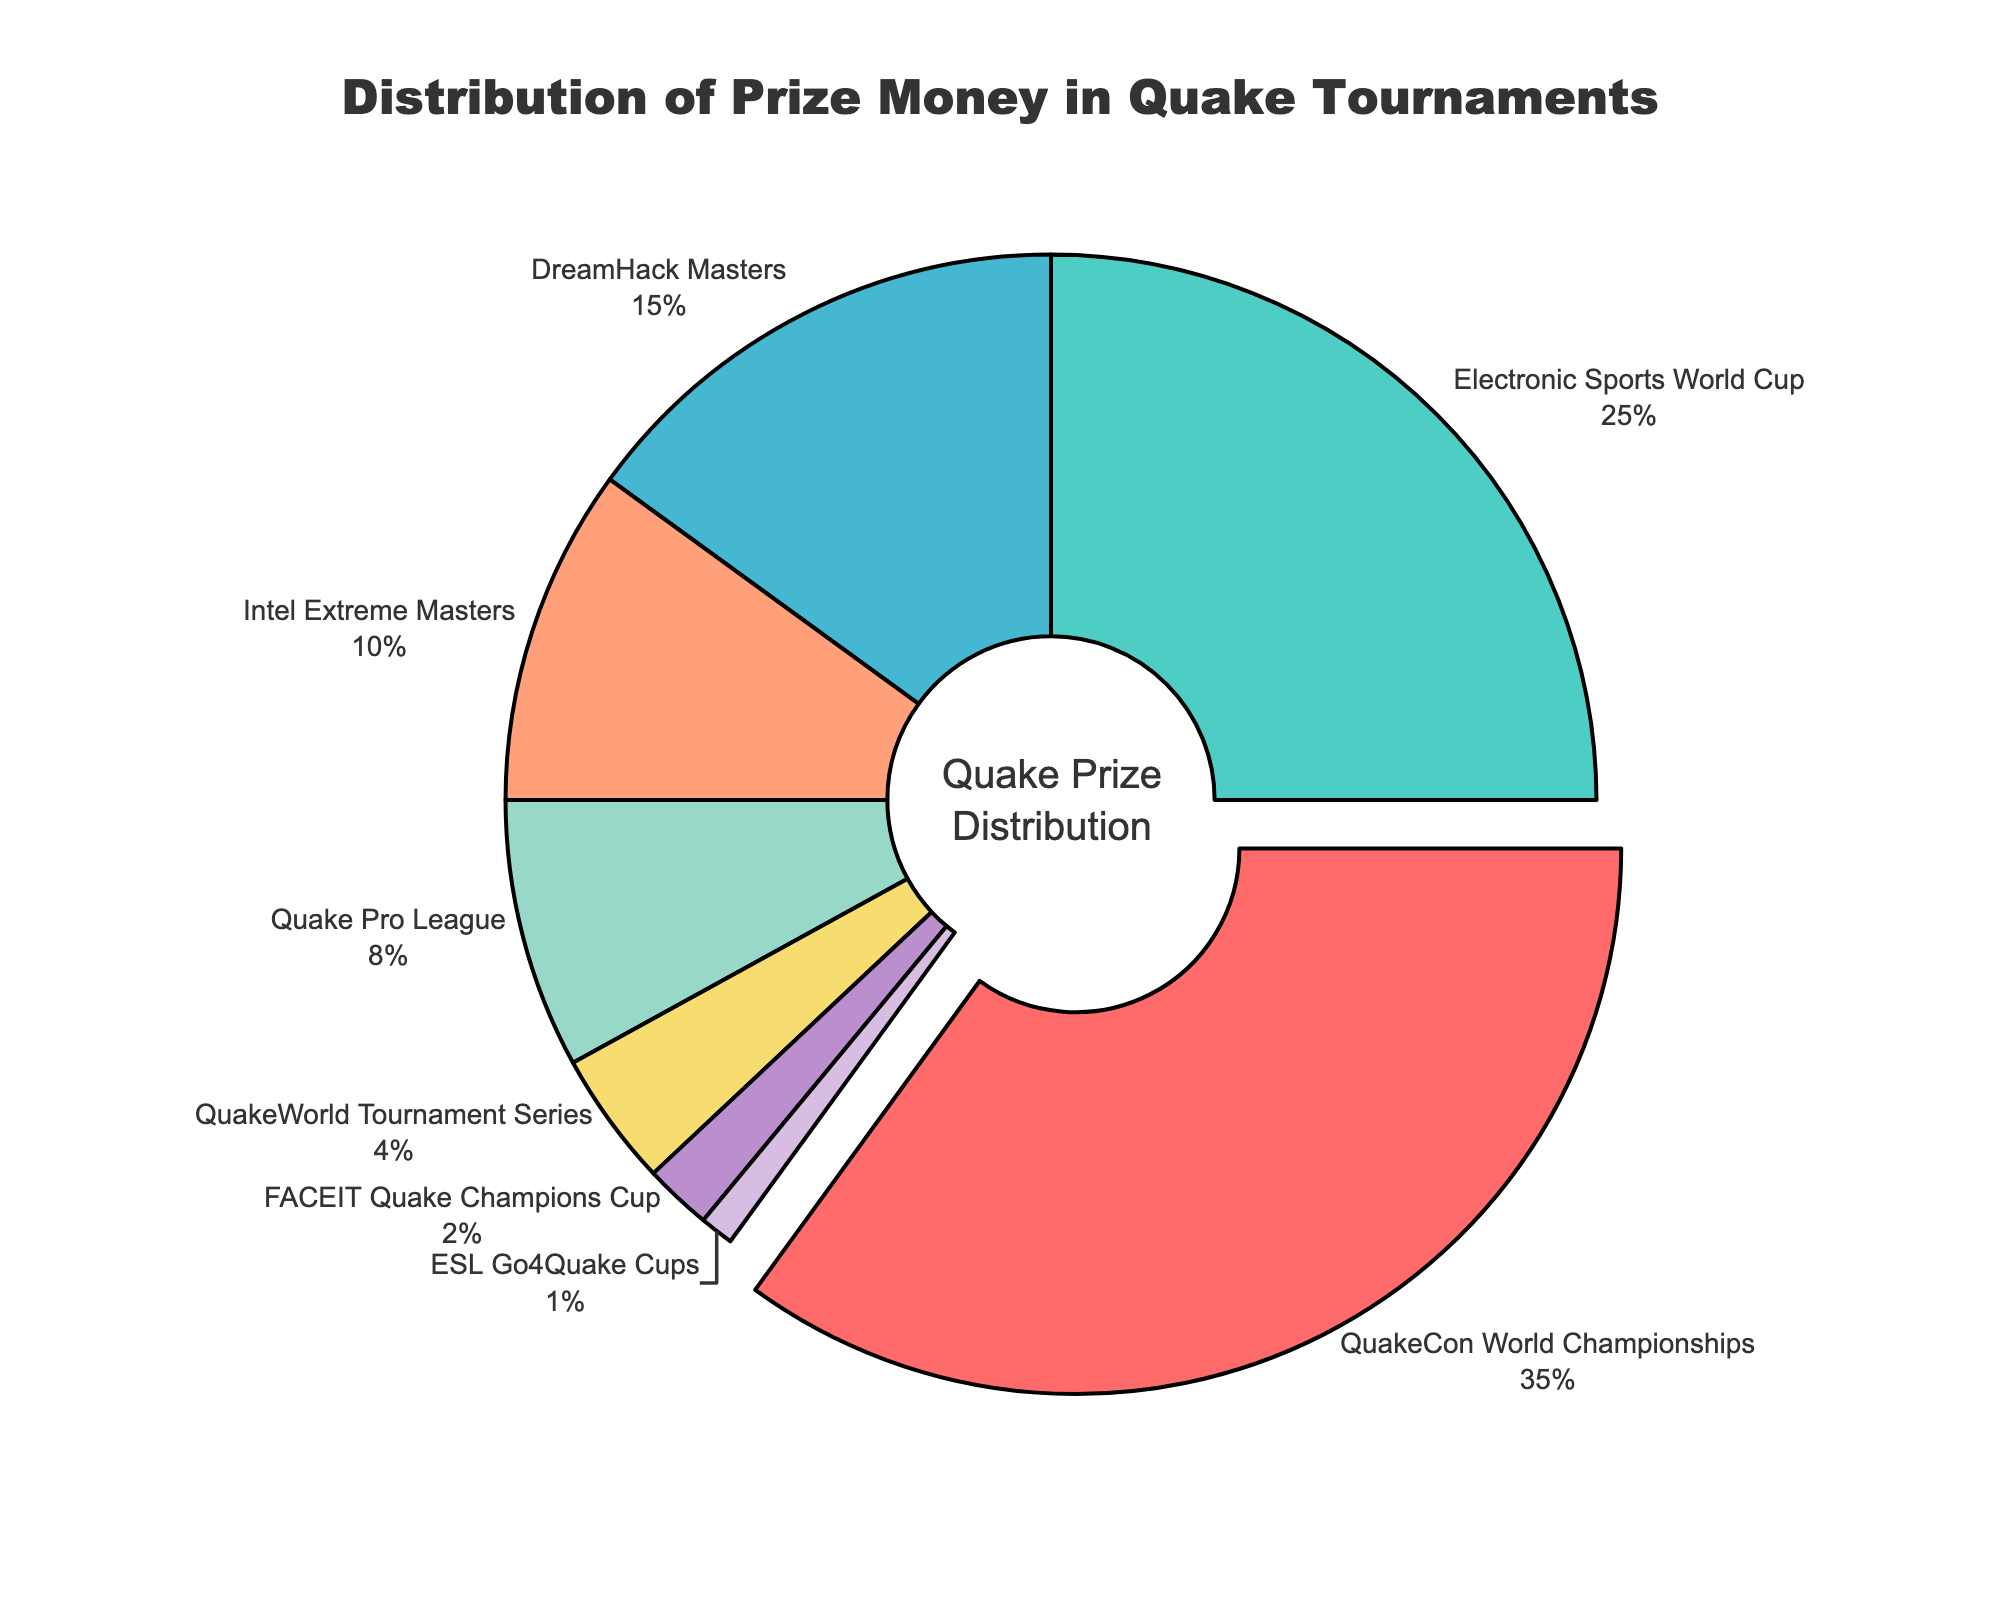What percentage of the prize money is distributed to QuakeCon World Championships and Electronic Sports World Cup combined? To find the combined percentage, add the prize money percentages of both tiers. QuakeCon World Championships has 35% and Electronic Sports World Cup has 25%. So, 35% + 25% = 60%.
Answer: 60% Does DreamHack Masters or Intel Extreme Masters offer a larger share of the prize money? By how much? Compare the percentages of prize money: DreamHack Masters has 15% and Intel Extreme Masters has 10%. The difference is 15% - 10% = 5%.
Answer: DreamHack Masters by 5% Is the prize money share of Quake Pro League more or less than that of QuakeWorld Tournament Series? Quake Pro League has a prize money share of 8% and QuakeWorld Tournament Series has 4%. Since 8% is greater than 4%, Quake Pro League has a larger share.
Answer: More Which tournament tier has the smallest share of prize money, and what percentage is it? Based on the chart, ESL Go4Quake Cups has the smallest share of prize money, which is 1%.
Answer: ESL Go4Quake Cups, 1% Are the combined shares of FACEIT Quake Champions Cup and QuakeWorld Tournament Series more or less than the share of Intel Extreme Masters? Faceit Quake Champions Cup has 2%, and QuakeWorld Tournament Series has 4%. Combined, they have 2% + 4% = 6%, which is less than Intel Extreme Masters' 10%.
Answer: Less What color represents the Quake Pro League in the chart, and what is its prize money percentage? The Quake Pro League is represented by green in the pie chart, and its prize money percentage is 8%.
Answer: Green, 8% Which tournament tier has a share exactly one-fourth that of DreamHack Masters? DreamHack Masters has a share of 15%. One-fourth of this is 15% / 4 = 3.75%. None of the other tiers have exactly this percentage, but QuakeWorld Tournament Series is the closest with 4%.
Answer: QuakeWorld Tournament Series By how much is the share of QuakeCon World Championships greater than the combined share of DreamHack Masters and Quake Pro League? QuakeCon World Championships has 35%. DreamHack Masters and Quake Pro League combined have 15% + 8% = 23%. The difference is 35% - 23% = 12%.
Answer: 12% Which tournaments collectively hold more than half of the total prize money? To determine this, add the shares of the top contributors until the sum exceeds 50%. QuakeCon World Championships (35%) and Electronic Sports World Cup (25%) together have 35% + 25% = 60%. These two tiers collectively hold more than half of the total prize money.
Answer: QuakeCon World Championships and Electronic Sports World Cup 